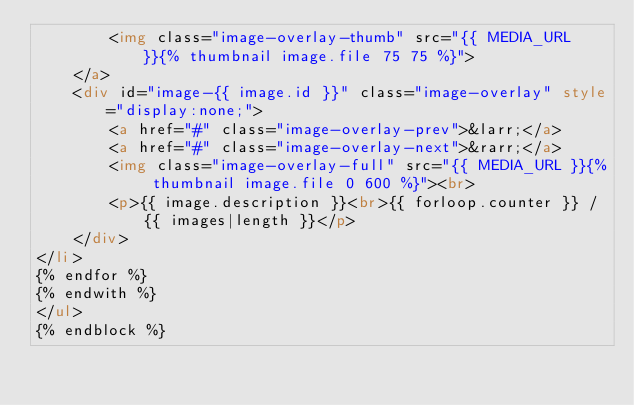<code> <loc_0><loc_0><loc_500><loc_500><_HTML_>        <img class="image-overlay-thumb" src="{{ MEDIA_URL }}{% thumbnail image.file 75 75 %}">
    </a>
    <div id="image-{{ image.id }}" class="image-overlay" style="display:none;">
        <a href="#" class="image-overlay-prev">&larr;</a>
        <a href="#" class="image-overlay-next">&rarr;</a>
        <img class="image-overlay-full" src="{{ MEDIA_URL }}{% thumbnail image.file 0 600 %}"><br>
        <p>{{ image.description }}<br>{{ forloop.counter }} / {{ images|length }}</p>
    </div>
</li>
{% endfor %}
{% endwith %}
</ul>
{% endblock %}

</code> 